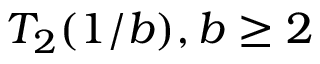Convert formula to latex. <formula><loc_0><loc_0><loc_500><loc_500>T _ { 2 } ( 1 / b ) , b \geq 2</formula> 